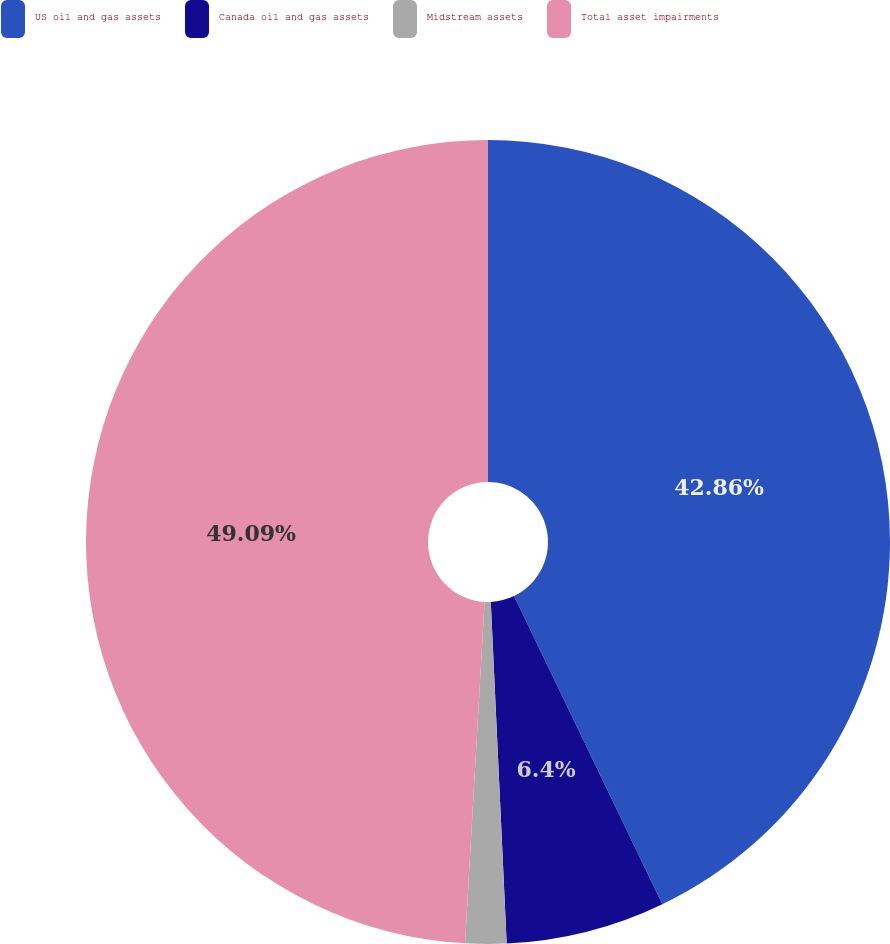Convert chart. <chart><loc_0><loc_0><loc_500><loc_500><pie_chart><fcel>US oil and gas assets<fcel>Canada oil and gas assets<fcel>Midstream assets<fcel>Total asset impairments<nl><fcel>42.86%<fcel>6.4%<fcel>1.65%<fcel>49.09%<nl></chart> 